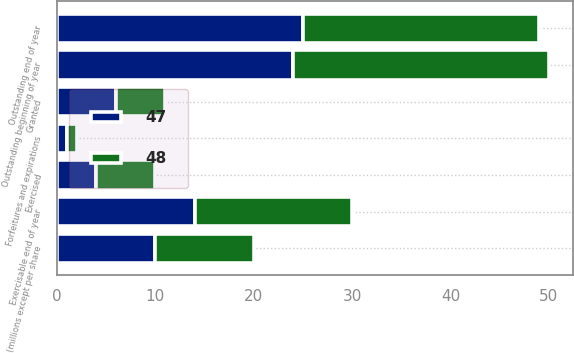Convert chart to OTSL. <chart><loc_0><loc_0><loc_500><loc_500><stacked_bar_chart><ecel><fcel>(millions except per share<fcel>Outstanding beginning of year<fcel>Granted<fcel>Exercised<fcel>Forfeitures and expirations<fcel>Outstanding end of year<fcel>Exercisable end of year<nl><fcel>47<fcel>10<fcel>24<fcel>6<fcel>4<fcel>1<fcel>25<fcel>14<nl><fcel>48<fcel>10<fcel>26<fcel>5<fcel>6<fcel>1<fcel>24<fcel>16<nl></chart> 